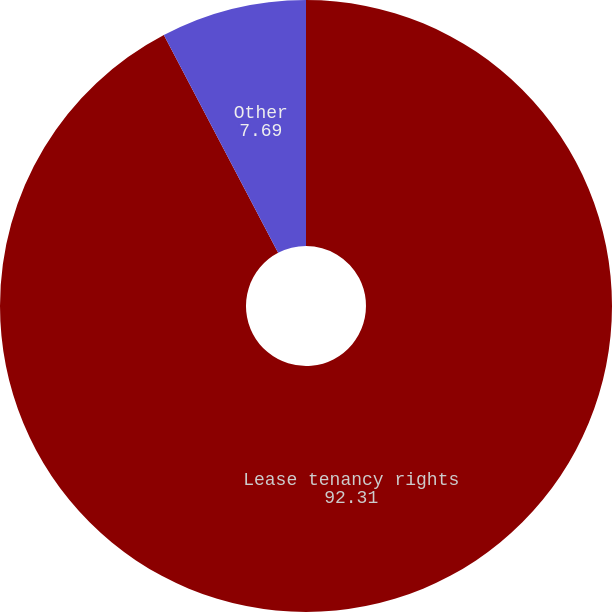<chart> <loc_0><loc_0><loc_500><loc_500><pie_chart><fcel>Lease tenancy rights<fcel>Other<nl><fcel>92.31%<fcel>7.69%<nl></chart> 